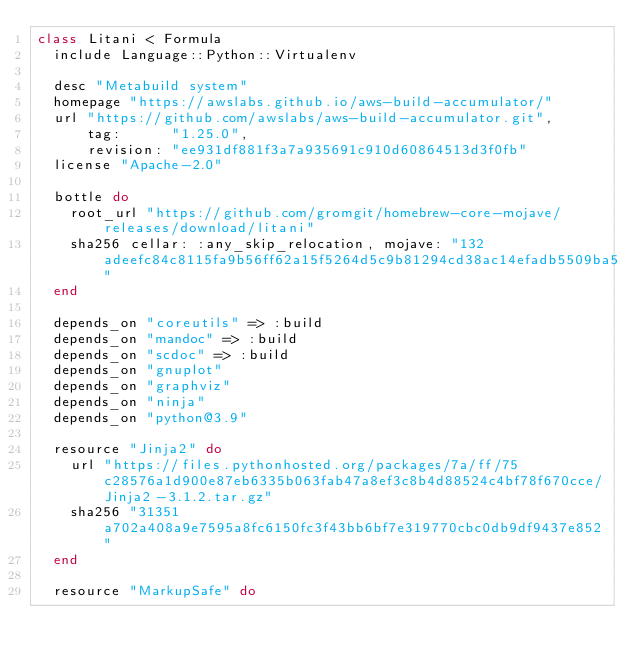Convert code to text. <code><loc_0><loc_0><loc_500><loc_500><_Ruby_>class Litani < Formula
  include Language::Python::Virtualenv

  desc "Metabuild system"
  homepage "https://awslabs.github.io/aws-build-accumulator/"
  url "https://github.com/awslabs/aws-build-accumulator.git",
      tag:      "1.25.0",
      revision: "ee931df881f3a7a935691c910d60864513d3f0fb"
  license "Apache-2.0"

  bottle do
    root_url "https://github.com/gromgit/homebrew-core-mojave/releases/download/litani"
    sha256 cellar: :any_skip_relocation, mojave: "132adeefc84c8115fa9b56ff62a15f5264d5c9b81294cd38ac14efadb5509ba5"
  end

  depends_on "coreutils" => :build
  depends_on "mandoc" => :build
  depends_on "scdoc" => :build
  depends_on "gnuplot"
  depends_on "graphviz"
  depends_on "ninja"
  depends_on "python@3.9"

  resource "Jinja2" do
    url "https://files.pythonhosted.org/packages/7a/ff/75c28576a1d900e87eb6335b063fab47a8ef3c8b4d88524c4bf78f670cce/Jinja2-3.1.2.tar.gz"
    sha256 "31351a702a408a9e7595a8fc6150fc3f43bb6bf7e319770cbc0db9df9437e852"
  end

  resource "MarkupSafe" do</code> 